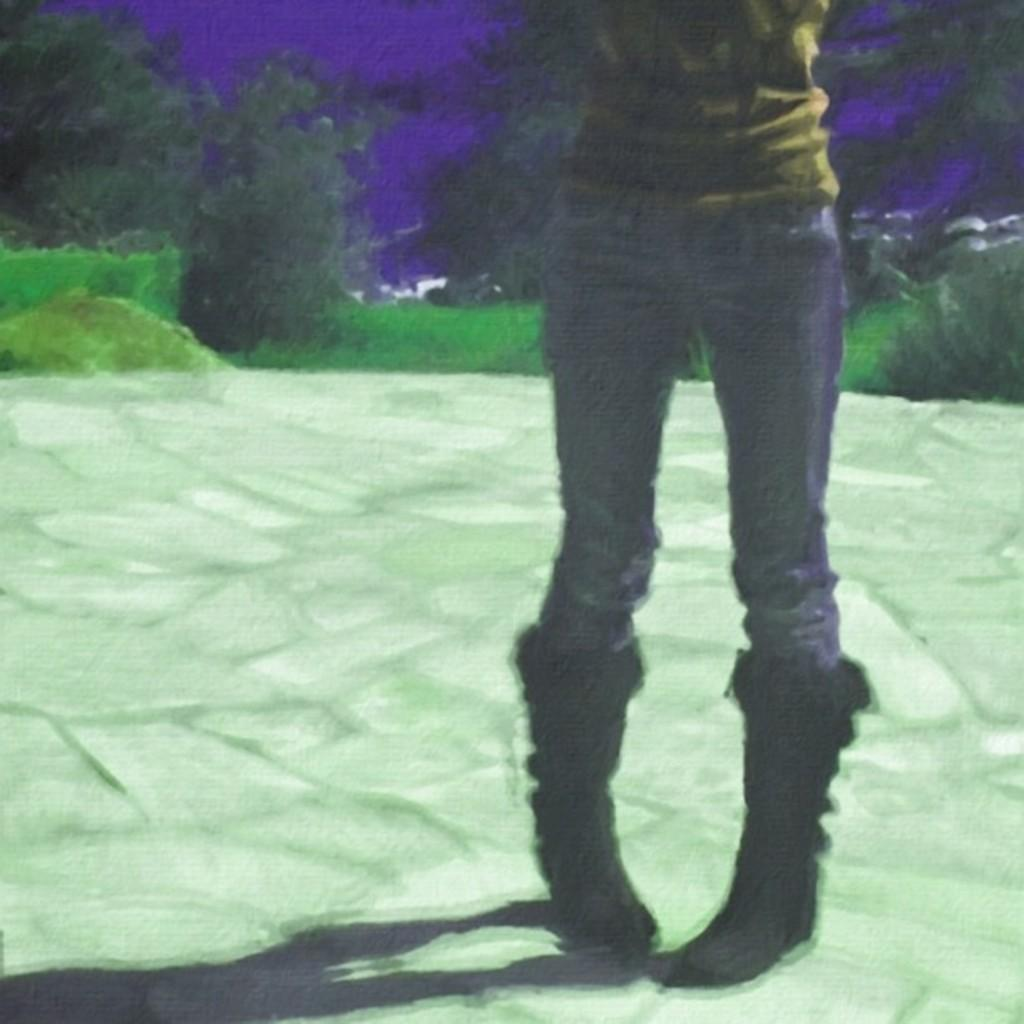What is the main subject of the image? There is a person standing in the image. What can be seen on the person's feet? The person is wearing shoes. What type of natural elements can be seen in the backdrop of the image? There are plants and trees in the backdrop of the image. How many icicles are hanging from the trees in the image? There are no icicles present in the image; it features a person standing and plants and trees in the backdrop. 